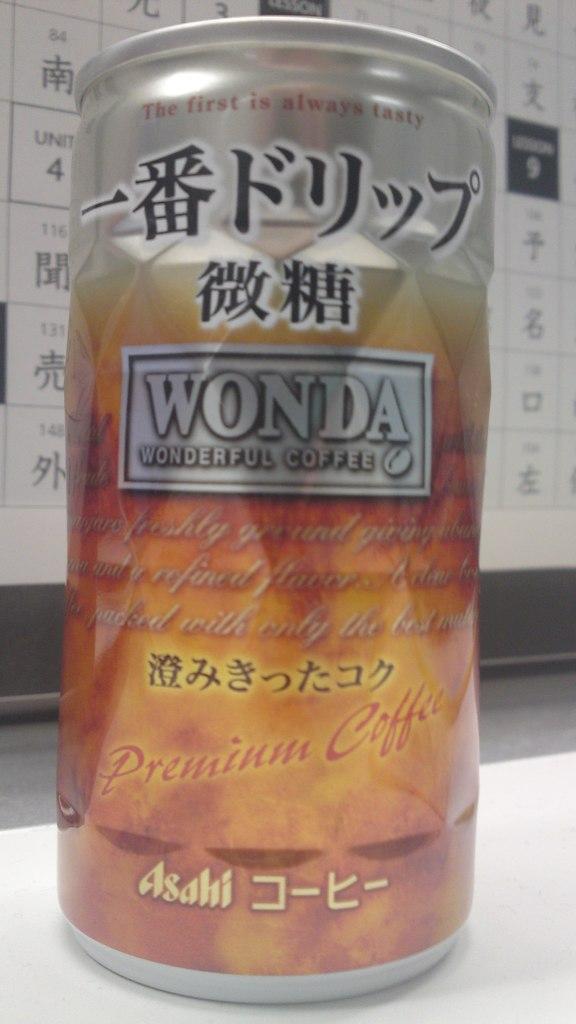What brand coffee is this?
Your answer should be compact. Wonda. 